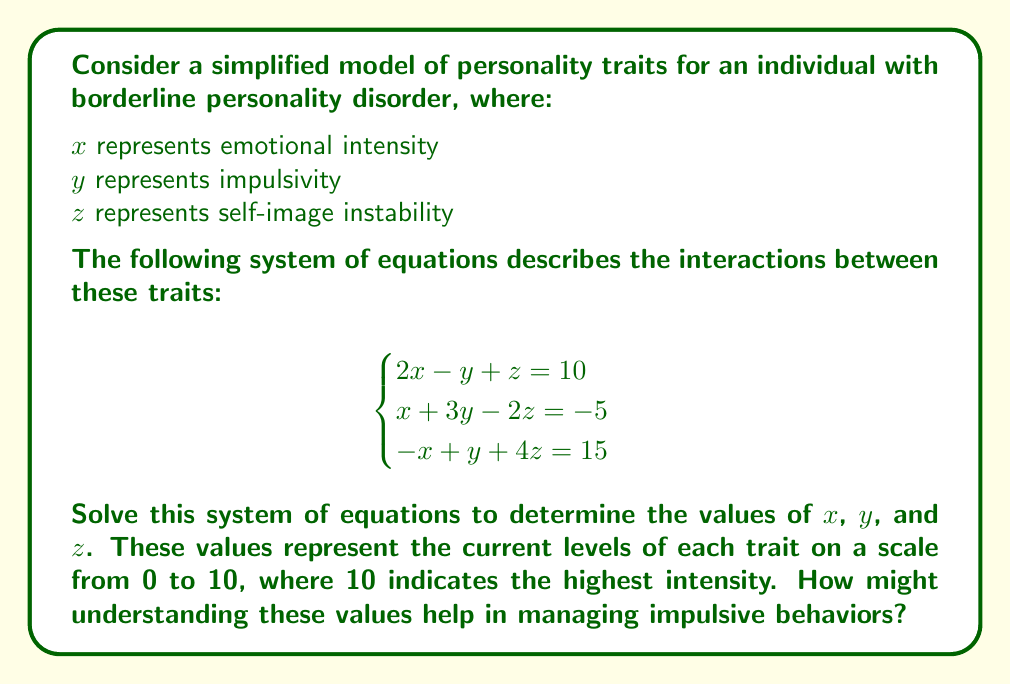Could you help me with this problem? Let's solve this system of equations using the elimination method:

Step 1: Multiply the first equation by 3 and the second equation by 2:
$$\begin{cases}
6x - 3y + 3z = 30 \\
2x + 6y - 4z = -10 \\
-x + y + 4z = 15
\end{cases}$$

Step 2: Add the first two equations to eliminate y:
$$8x - z = 20$$ (Equation 4)

Step 3: Multiply Equation 4 by 1 and add it to the third equation:
$$7x + 3z = 35$$ (Equation 5)

Step 4: Multiply Equation 4 by 3 and Equation 5 by -1:
$$\begin{cases}
24x - 3z = 60 \\
-7x - 3z = -35
\end{cases}$$

Step 5: Add these equations:
$$17x = 25$$
$$x = \frac{25}{17}$$

Step 6: Substitute x into Equation 4:
$$8(\frac{25}{17}) - z = 20$$
$$z = \frac{200}{17} - 20 = \frac{-140}{17}$$

Step 7: Substitute x and z into the first original equation:
$$2(\frac{25}{17}) - y + (\frac{-140}{17}) = 10$$
$$y = \frac{50}{17} - \frac{140}{17} - 10 = \frac{-160}{17}$$

Therefore, $x = \frac{25}{17}$, $y = \frac{-160}{17}$, and $z = \frac{-140}{17}$.

Understanding these values can help in managing impulsive behaviors by:
1. Recognizing that emotional intensity (x) is relatively high, which may contribute to impulsivity.
2. Noting that the current impulsivity level (y) is negative, suggesting a temporary state of inhibition.
3. Observing that self-image instability (z) is negative, indicating a potential period of more stable self-perception.

This information can be used to develop targeted strategies for maintaining emotional balance and reinforcing positive behaviors during this period of relative stability.
Answer: $x = \frac{25}{17}$, $y = \frac{-160}{17}$, $z = \frac{-140}{17}$ 